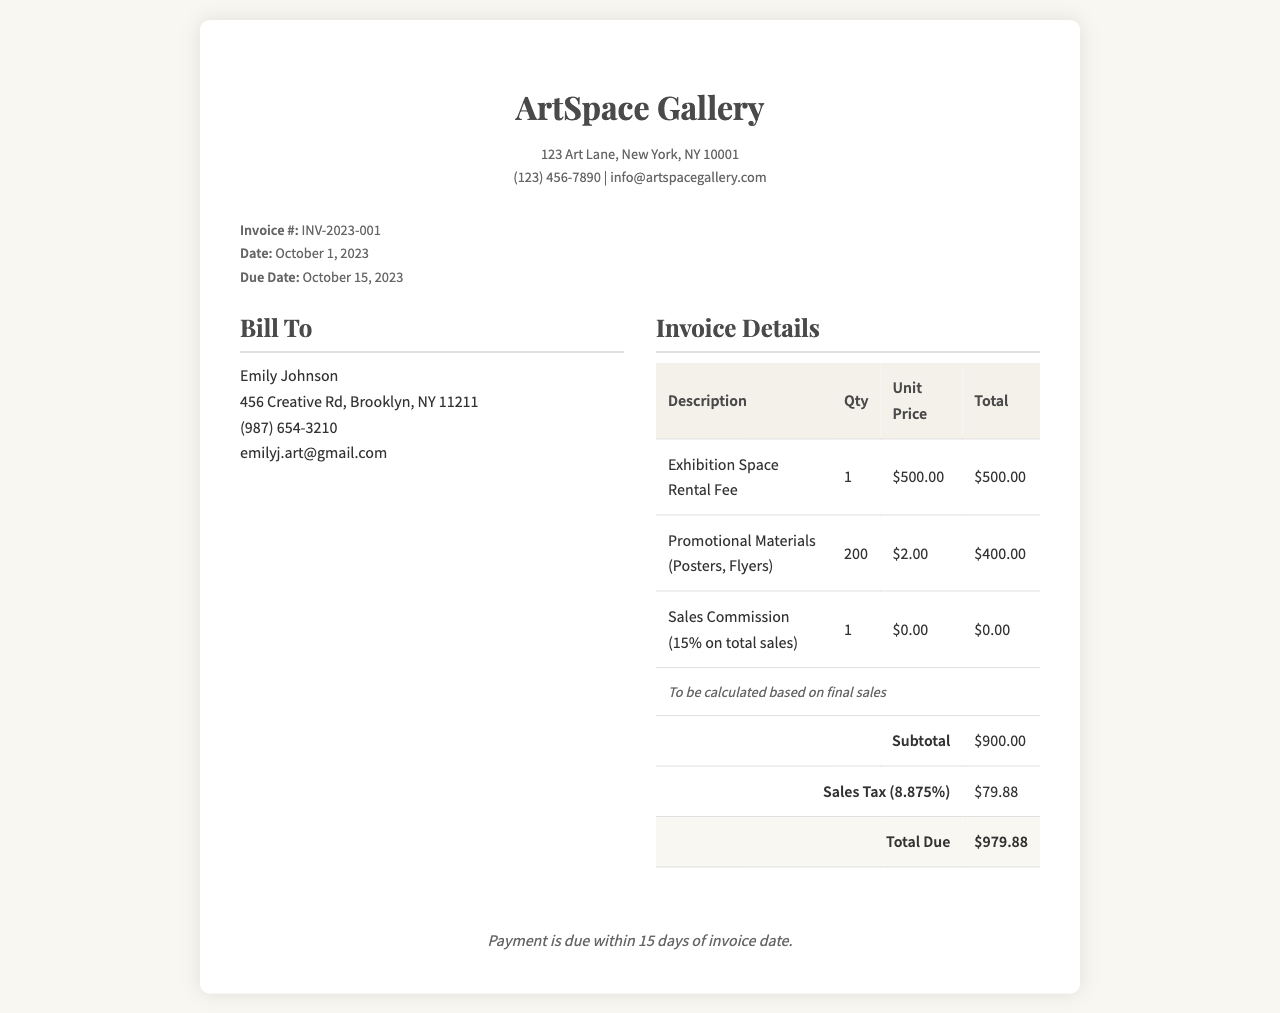What is the invoice number? The invoice number can be found in the invoice information section, listed as "Invoice #: INV-2023-001."
Answer: INV-2023-001 What is the due date for payment? The due date is specified under the invoice information as "Due Date: October 15, 2023."
Answer: October 15, 2023 Who is the billing recipient? The recipient's name appears in the "Bill To" section as "Emily Johnson."
Answer: Emily Johnson What is the total amount due? The total due is provided at the end of the invoice details, shown as "Total Due: $979.88."
Answer: $979.88 What is the unit price for promotional materials? The unit price for promotional materials is detailed in the invoice, noted as "$2.00."
Answer: $2.00 How much is the sales tax? The sales tax amount can be found in the invoice details, indicated as "Sales Tax (8.875%): $79.88."
Answer: $79.88 What is the subtotal for the services? The subtotal for the services is marked in the invoice details as "$900.00."
Answer: $900.00 What is the percentage of sales commission? The percentage of sales commission is mentioned in the invoice under "Sales Commission," which states "15% on total sales."
Answer: 15% When was the invoice issued? The invoice issued date is found in the invoice information section as "Date: October 1, 2023."
Answer: October 1, 2023 